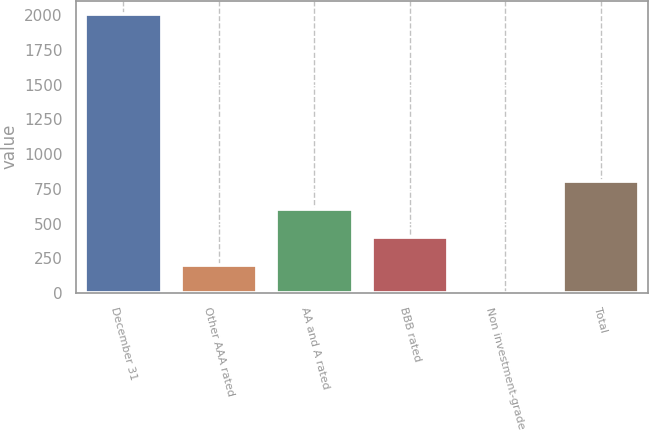Convert chart to OTSL. <chart><loc_0><loc_0><loc_500><loc_500><bar_chart><fcel>December 31<fcel>Other AAA rated<fcel>AA and A rated<fcel>BBB rated<fcel>Non investment-grade<fcel>Total<nl><fcel>2005<fcel>202.66<fcel>603.18<fcel>402.92<fcel>2.4<fcel>803.44<nl></chart> 